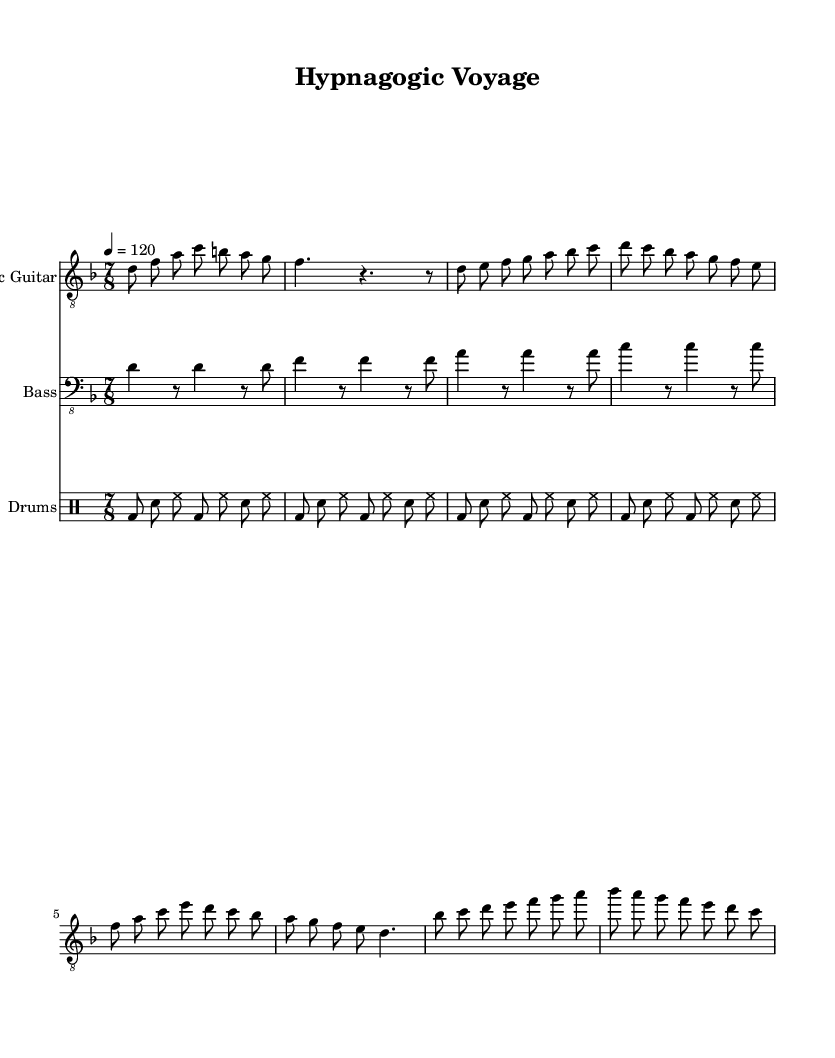What is the key signature of this music? The key signature indicates the notes used in the piece. Here, the key signature is D minor, which typically includes one flat (B flat).
Answer: D minor What is the time signature? The time signature shows how many beats are in each measure. Here, it is 7/8, meaning there are seven eighth notes in each measure.
Answer: 7/8 What is the tempo marking? The tempo marking specifies how fast the piece should be played. The marking shows a speed of 120 beats per minute, which means it should be played moderately fast.
Answer: 120 How many measures are in the electric guitar part? By counting the distinct block of notes and rests shown in the electric guitar part, we see there are 8 measures in total.
Answer: 8 What is the rhythmic pattern used in the bass guitar part? The bass guitar part consistently uses a basic rhythm pattern alternating between quarter notes and rests, which qualifies as a standard rock rhythm. The pattern repeats throughout the part.
Answer: Basic rhythm pattern Which instrument plays the first part of the score? The first part of the score corresponds to the electric guitar, as it is listed first in the instrument order and has its own staff.
Answer: Electric Guitar What musical style does this sheet music represent? The presence of progressive structures, complex time signatures, and the thematic emphasis on dream states indicate that this music is in the progressive rock genre.
Answer: Progressive rock 